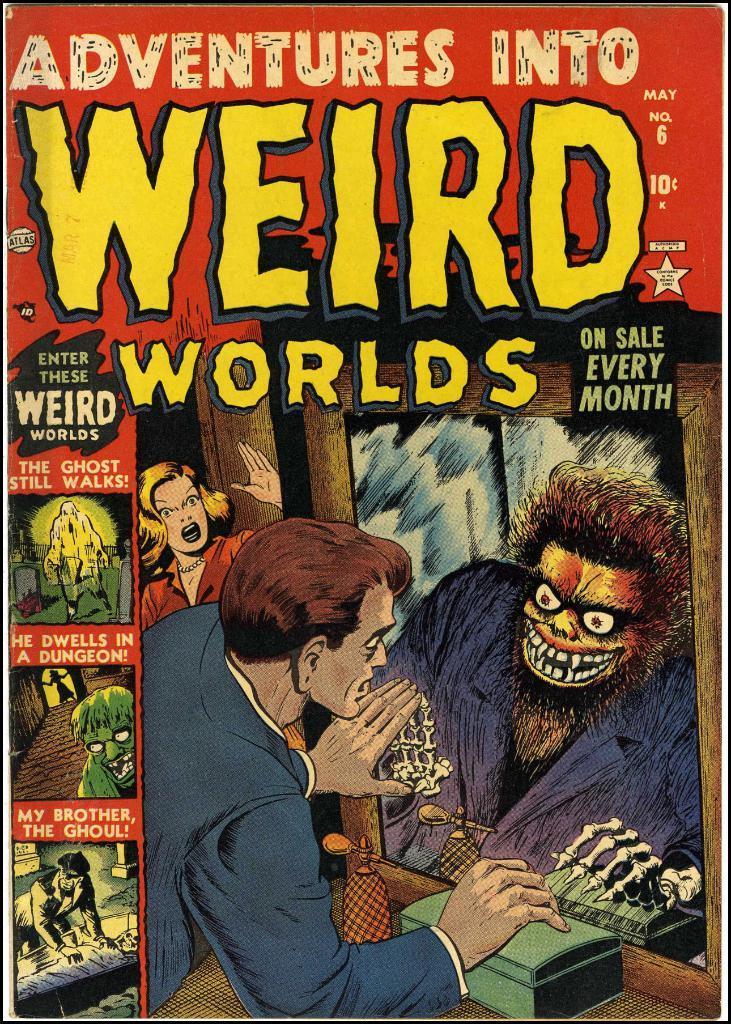Can you describe this image briefly? It is a book, there are photographs on it. At the bottom a man is looking into the mirror, there is a ghost in the mirror. On the left side a woman is there. 